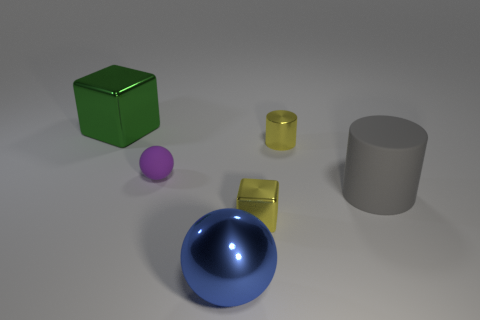Add 4 green balls. How many objects exist? 10 Subtract all cylinders. How many objects are left? 4 Subtract 1 yellow cubes. How many objects are left? 5 Subtract all large blue matte blocks. Subtract all large gray cylinders. How many objects are left? 5 Add 5 metal blocks. How many metal blocks are left? 7 Add 5 tiny gray balls. How many tiny gray balls exist? 5 